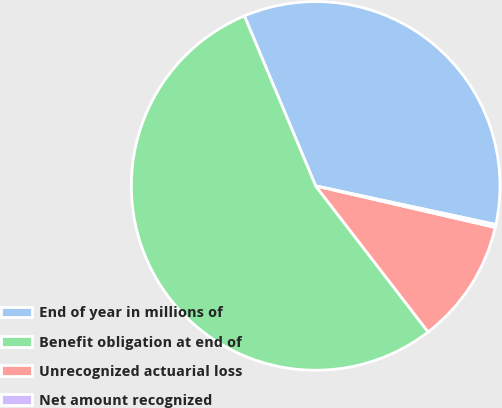Convert chart to OTSL. <chart><loc_0><loc_0><loc_500><loc_500><pie_chart><fcel>End of year in millions of<fcel>Benefit obligation at end of<fcel>Unrecognized actuarial loss<fcel>Net amount recognized<nl><fcel>34.68%<fcel>54.12%<fcel>10.94%<fcel>0.26%<nl></chart> 